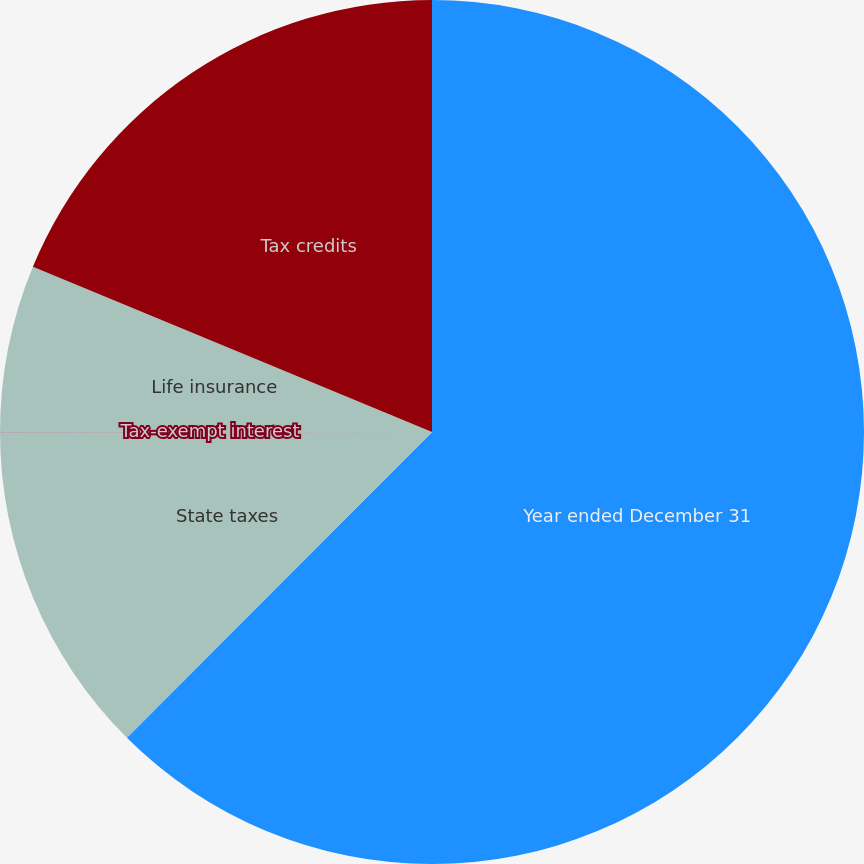<chart> <loc_0><loc_0><loc_500><loc_500><pie_chart><fcel>Year ended December 31<fcel>State taxes<fcel>Tax-exempt interest<fcel>Life insurance<fcel>Tax credits<nl><fcel>62.48%<fcel>12.5%<fcel>0.01%<fcel>6.26%<fcel>18.75%<nl></chart> 